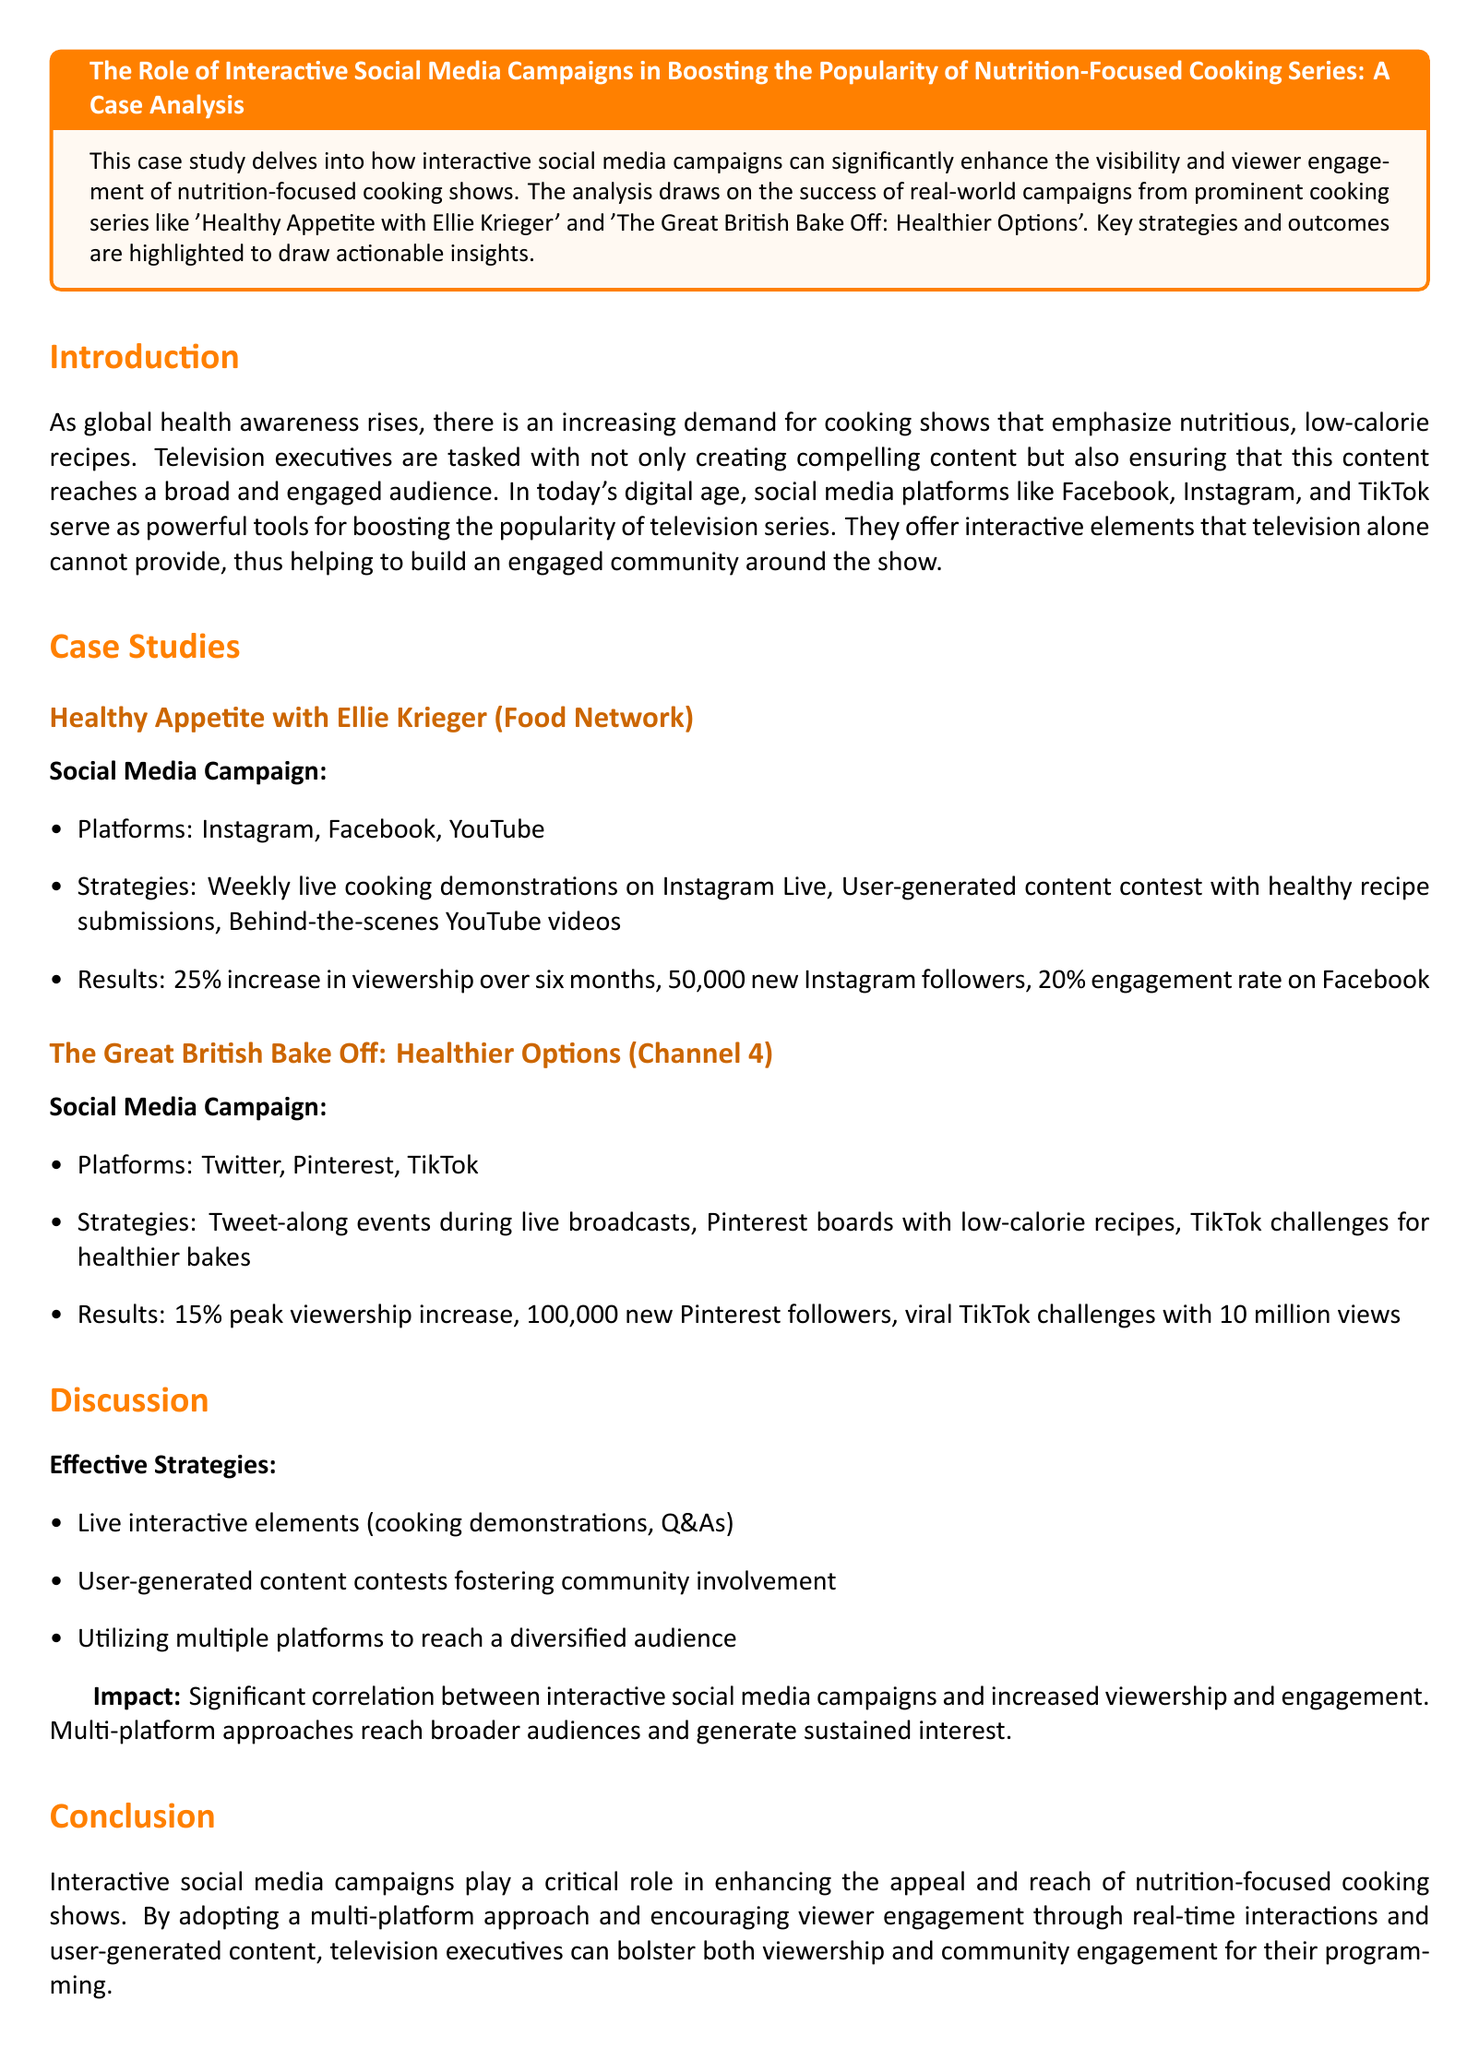what is the title of the case study? The title is presented at the beginning of the document in a highlighted box.
Answer: The Role of Interactive Social Media Campaigns in Boosting the Popularity of Nutrition-Focused Cooking Series: A Case Analysis which cooking show had a 25% increase in viewership? This information is detailed in the case study section under the first cooking series.
Answer: Healthy Appetite with Ellie Krieger what social media platform was NOT used by The Great British Bake Off? The platforms used are listed, and one is identified as missing in the document.
Answer: Instagram what was the engagement rate on Facebook for Healthy Appetite? The specific engagement rate is noted in the results for the first cooking series.
Answer: 20% how many new Pinterest followers did The Great British Bake Off gain? The document specifies the new followers gained as part of the social media campaign's outcomes.
Answer: 100,000 what strategy was used to foster community involvement in the cooking series? This involves reasoning across the strategies mentioned under both cooking shows.
Answer: User-generated content contests which TikTok challenges reached 10 million views? The TikTok challenges are specifically mentioned for the second cooking series and their achievements.
Answer: Healthier bakes what is a key effective strategy mentioned in the discussion? Effective strategies for boosting engagement and viewership are summarized in the discussion section.
Answer: Live interactive elements how did interactive social media campaigns impact viewership? The impact is discussed as a correlation between campaigns and viewer metrics.
Answer: Significant correlation 